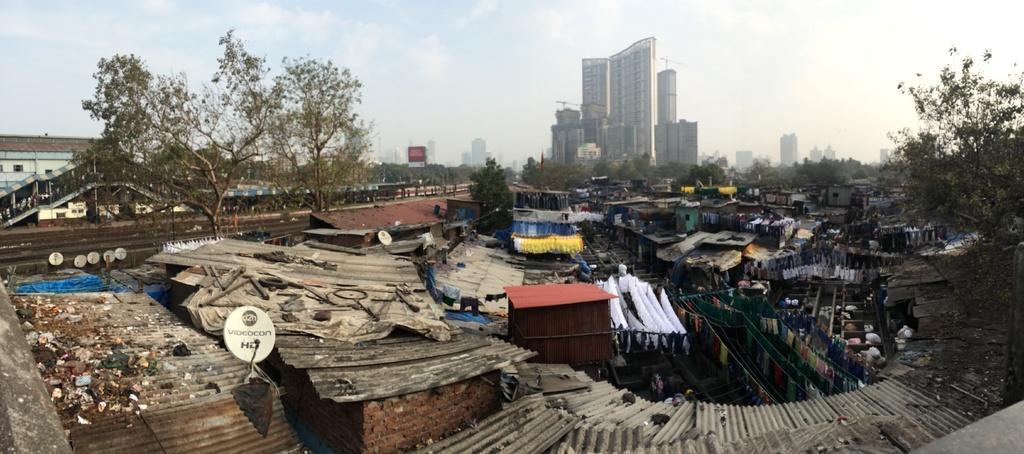How would you summarize this image in a sentence or two? In this image I can see few sheds, background I can see trees in green color, building in white color, sky in white and blue color. 